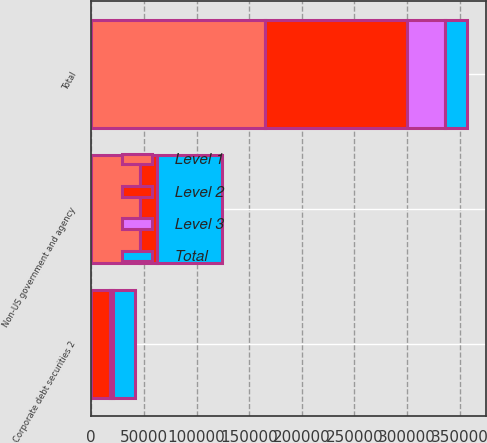<chart> <loc_0><loc_0><loc_500><loc_500><stacked_bar_chart><ecel><fcel>Non-US government and agency<fcel>Corporate debt securities 2<fcel>Total<nl><fcel>Level 1<fcel>46715<fcel>111<fcel>164712<nl><fcel>Level 2<fcel>15509<fcel>18049<fcel>135374<nl><fcel>Level 3<fcel>26<fcel>2821<fcel>35749<nl><fcel>Total<fcel>62250<fcel>20981<fcel>20981<nl></chart> 